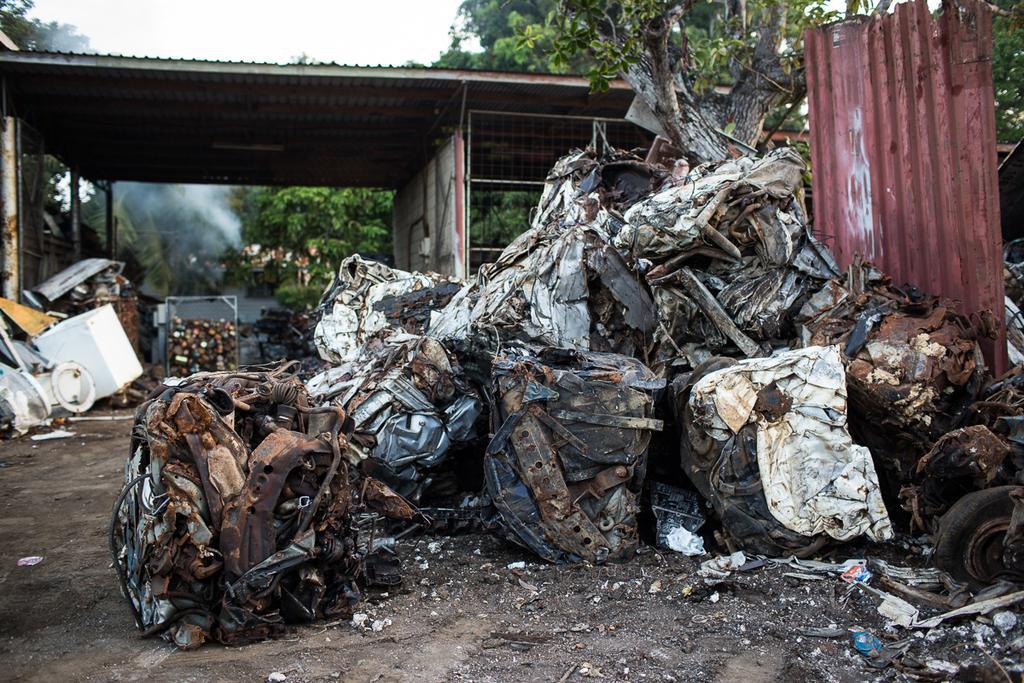Describe this image in one or two sentences. In this picture we can see scrap near to the iron sheet. Here we can see shed. On the top we can see sky and clouds. Here we can see many trees. 